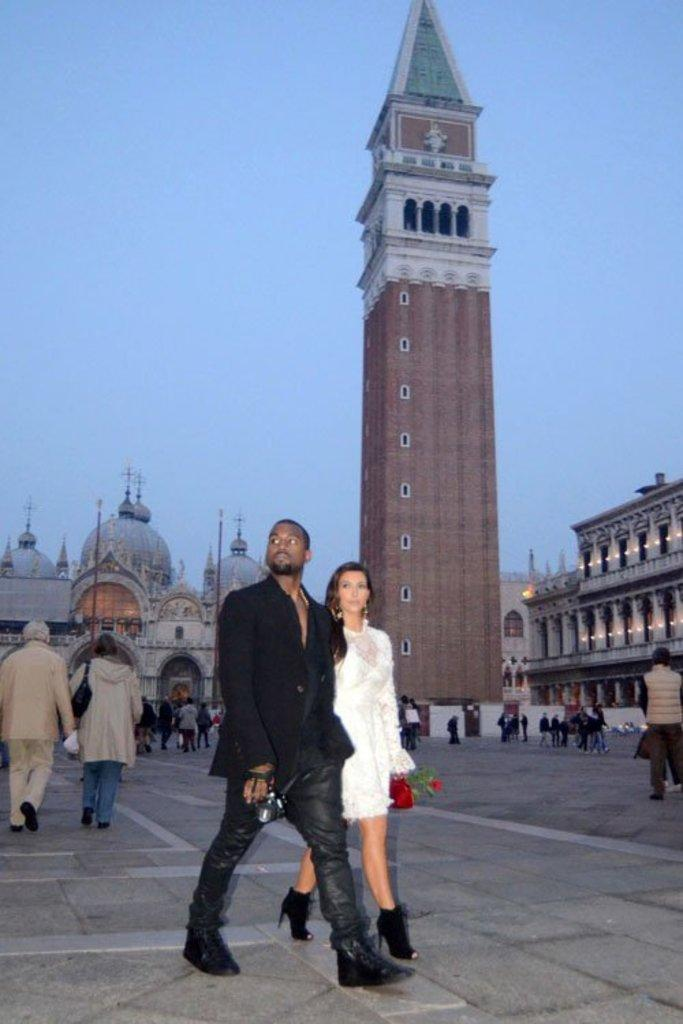How many people are present in the image? There are two people, a woman and a man, present in the image. What are the woman and man doing in the image? The woman and man are walking on a path in the image. What can be seen in the background of the image? There are buildings, people, a tower, poles, walls, pillars, lights, and other objects in the background of the image. What part of the natural environment is visible in the image? The sky is visible in the background of the image. What type of watch is the woman wearing in the image? There is no watch visible on the woman in the image. What type of skirt is the man wearing in the image? The man is not wearing a skirt in the image, as he is dressed in typical male clothing. What government policies are being discussed in the image? There is no indication in the image that any government policies are being discussed. 